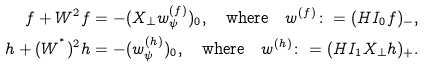<formula> <loc_0><loc_0><loc_500><loc_500>f + W ^ { 2 } f & = - ( X _ { \perp } w ^ { ( f ) } _ { \psi } ) _ { 0 } , \quad \text {where} \quad w ^ { ( f ) } \colon = ( H I _ { 0 } f ) _ { - } , \\ h + ( W ^ { ^ { * } } ) ^ { 2 } h & = - ( w ^ { ( h ) } _ { \psi } ) _ { 0 } , \quad \text {where} \quad w ^ { ( h ) } \colon = ( H I _ { 1 } X _ { \perp } h ) _ { + } .</formula> 